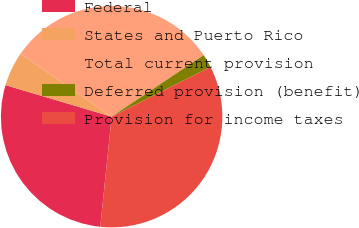<chart> <loc_0><loc_0><loc_500><loc_500><pie_chart><fcel>Federal<fcel>States and Puerto Rico<fcel>Total current provision<fcel>Deferred provision (benefit)<fcel>Provision for income taxes<nl><fcel>27.96%<fcel>5.02%<fcel>31.0%<fcel>1.97%<fcel>34.05%<nl></chart> 